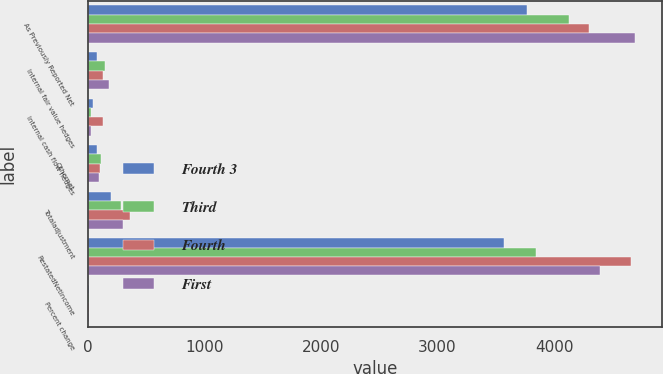Convert chart. <chart><loc_0><loc_0><loc_500><loc_500><stacked_bar_chart><ecel><fcel>As Previously Reported Net<fcel>Internal fair value hedges<fcel>Internal cash flow hedges<fcel>Othernet<fcel>Totaladjustment<fcel>RestatedNetincome<fcel>Percent change<nl><fcel>Fourth 3<fcel>3768<fcel>74<fcel>43<fcel>77<fcel>194<fcel>3574<fcel>5.1<nl><fcel>Third<fcel>4127<fcel>148<fcel>29<fcel>108<fcel>285<fcel>3841<fcel>6.9<nl><fcel>Fourth<fcel>4296<fcel>130<fcel>125<fcel>106<fcel>361<fcel>4657<fcel>8.4<nl><fcel>First<fcel>4695<fcel>179<fcel>28<fcel>95<fcel>302<fcel>4393<fcel>6.4<nl></chart> 